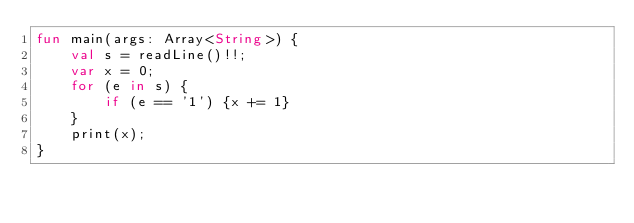Convert code to text. <code><loc_0><loc_0><loc_500><loc_500><_Kotlin_>fun main(args: Array<String>) {
	val s = readLine()!!;
	var x = 0;
	for (e in s) {
		if (e == '1') {x += 1}
	}
	print(x);
}

</code> 